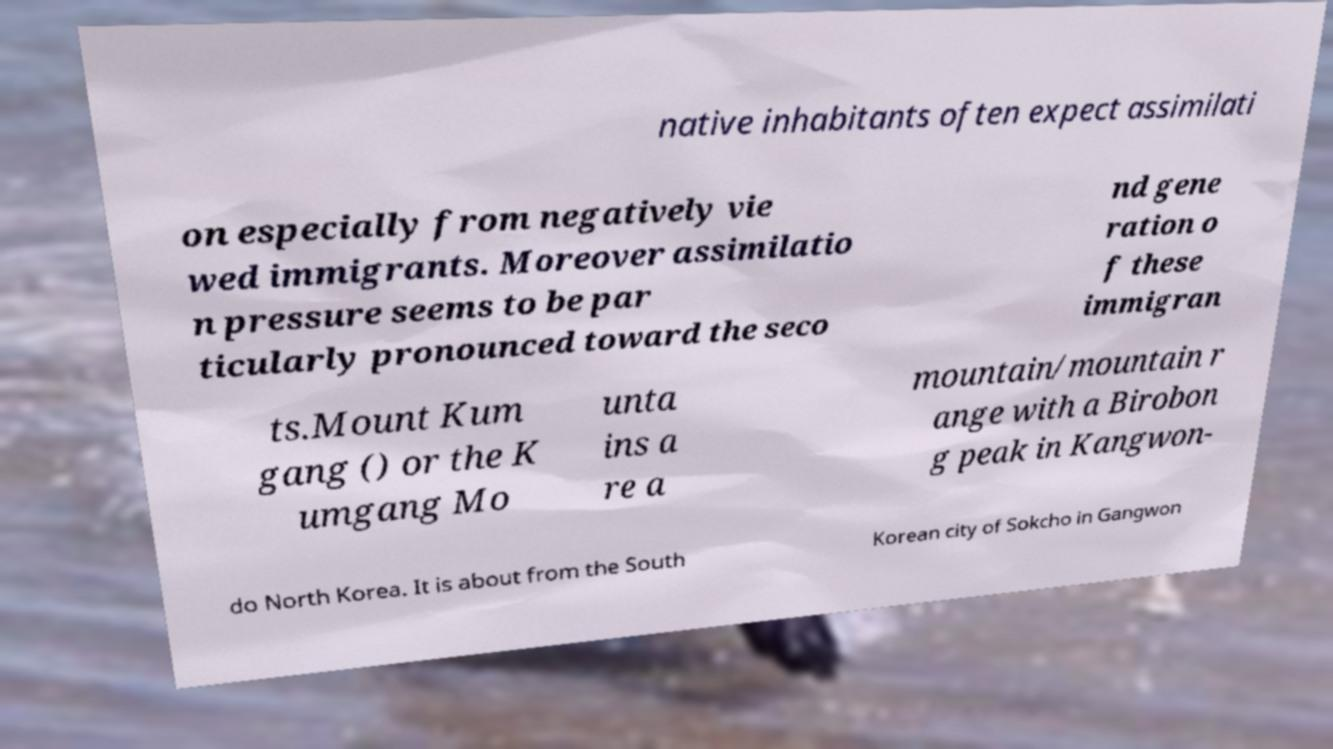Please identify and transcribe the text found in this image. native inhabitants often expect assimilati on especially from negatively vie wed immigrants. Moreover assimilatio n pressure seems to be par ticularly pronounced toward the seco nd gene ration o f these immigran ts.Mount Kum gang () or the K umgang Mo unta ins a re a mountain/mountain r ange with a Birobon g peak in Kangwon- do North Korea. It is about from the South Korean city of Sokcho in Gangwon 